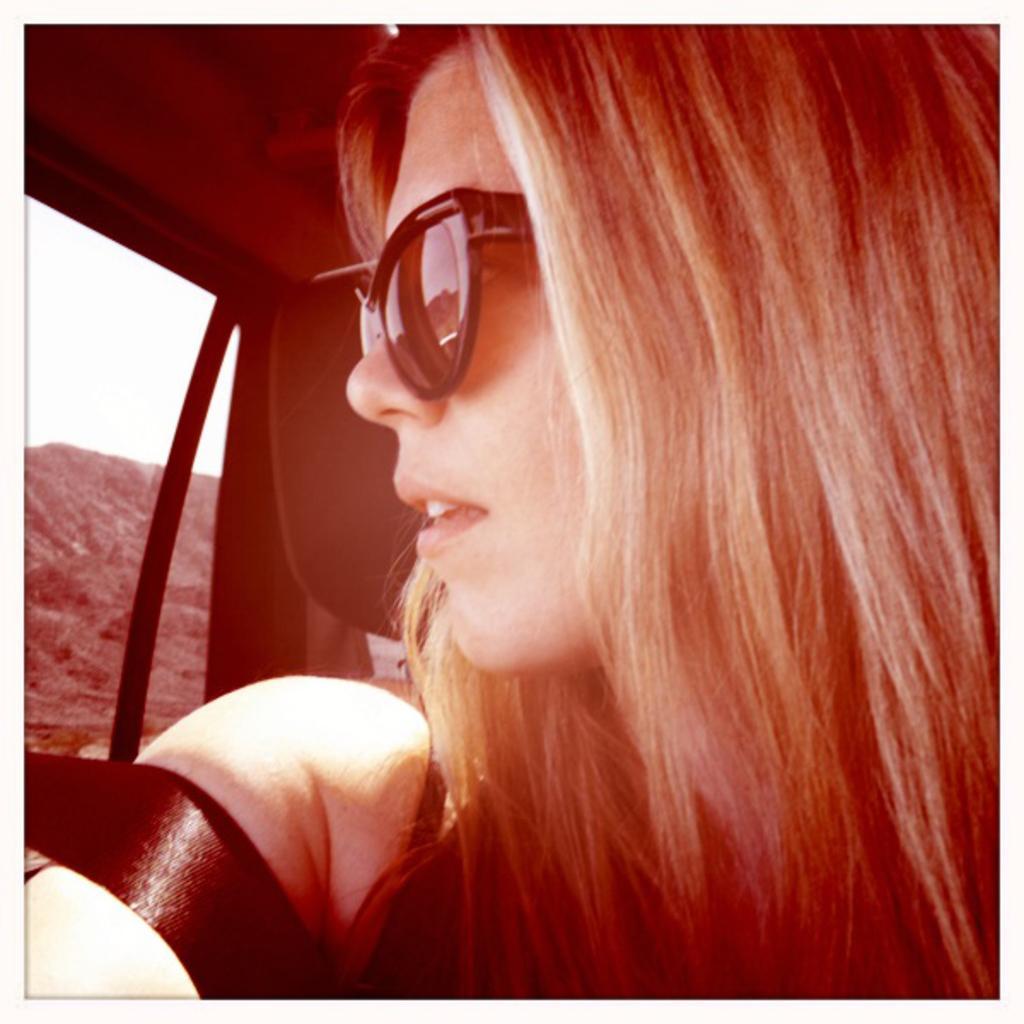In one or two sentences, can you explain what this image depicts? This picture taken from inside a car as we can see there is a women on the right side of this image and there is a window glass on the left side of this image. 